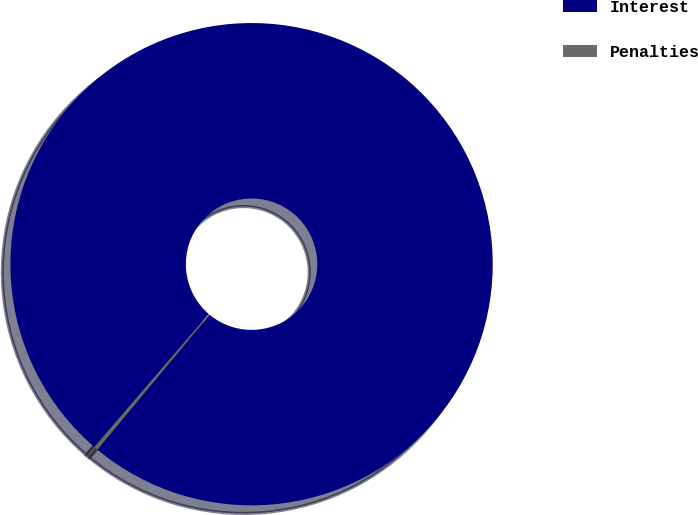Convert chart to OTSL. <chart><loc_0><loc_0><loc_500><loc_500><pie_chart><fcel>Interest<fcel>Penalties<nl><fcel>99.74%<fcel>0.26%<nl></chart> 